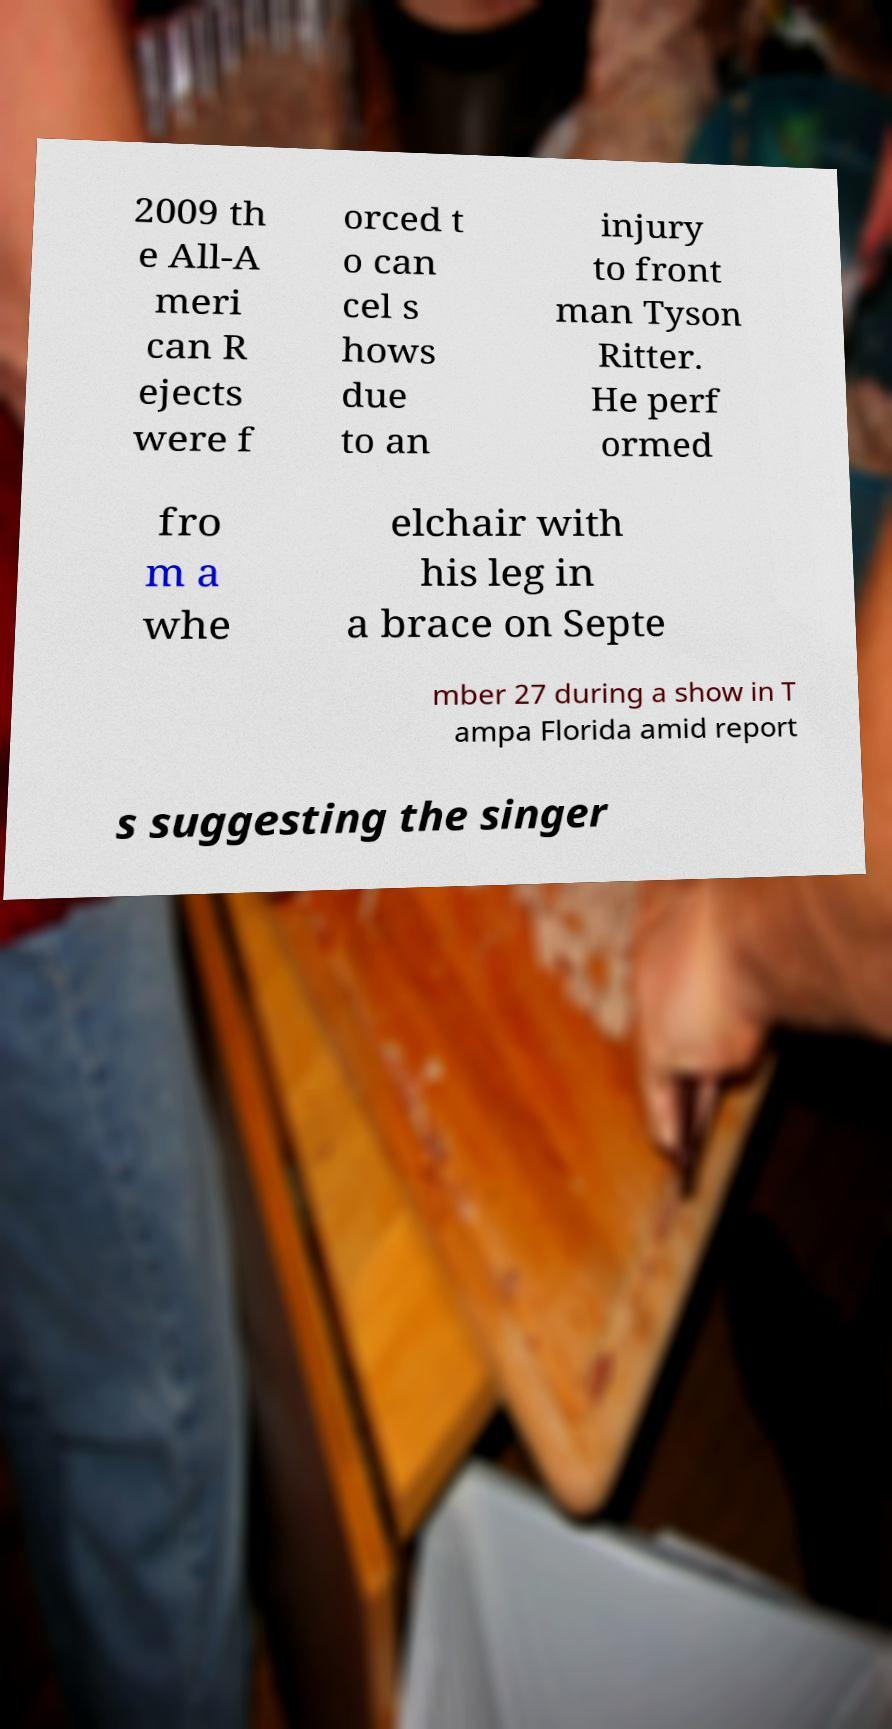Could you assist in decoding the text presented in this image and type it out clearly? 2009 th e All-A meri can R ejects were f orced t o can cel s hows due to an injury to front man Tyson Ritter. He perf ormed fro m a whe elchair with his leg in a brace on Septe mber 27 during a show in T ampa Florida amid report s suggesting the singer 